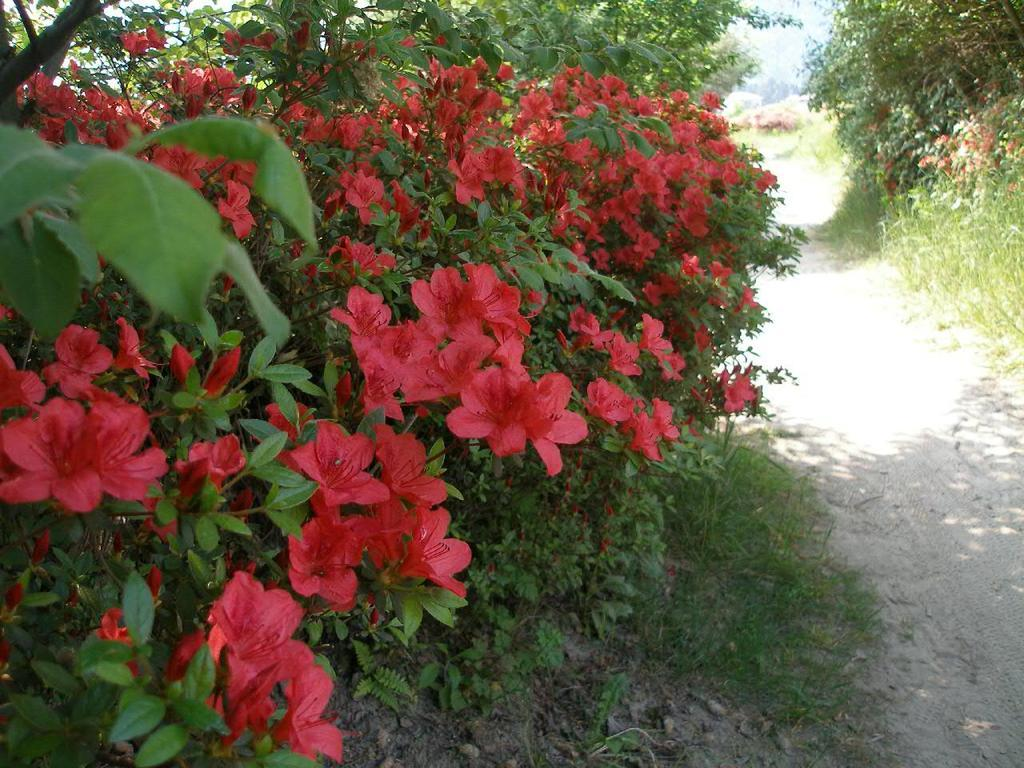What type of plants are present in the image? There are plants with flowers in the image. What type of vegetation is visible in the image? There is grass visible in the image. What kind of feature is present for walking in the image? There is a walking path in the image. What type of art can be seen hanging on the plants in the image? There is no art present in the image, as it features plants with flowers and grass. What type of beef dish is being served on the walking path in the image? There is no beef dish present in the image, as it features plants with flowers, grass, and a walking path. 